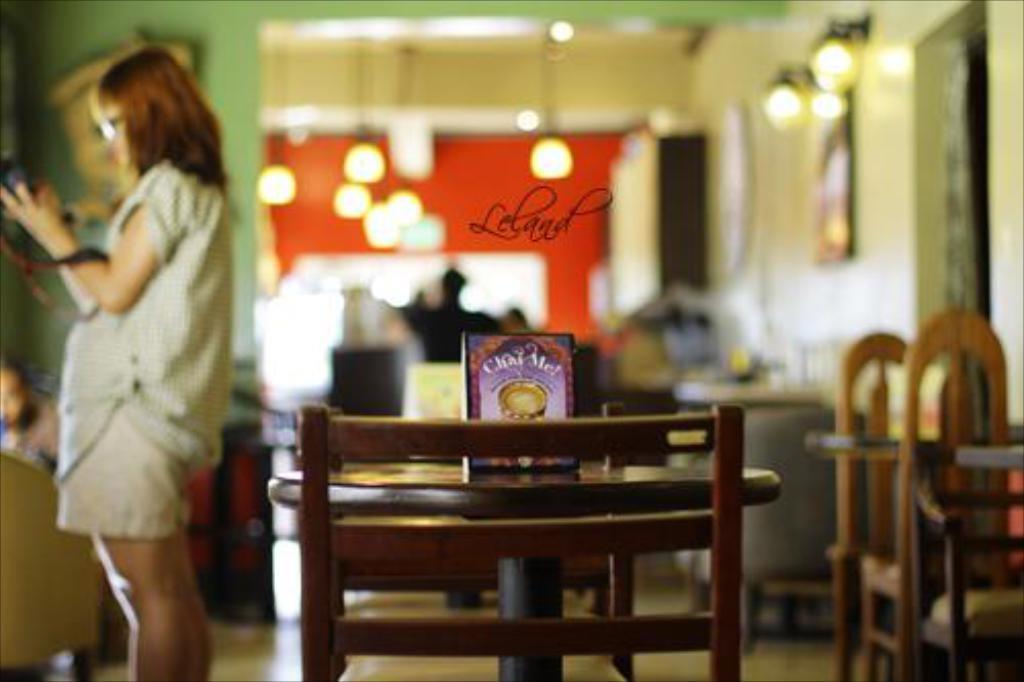How would you summarize this image in a sentence or two? In this image i can see a table and a person standing at the left side of the image. 